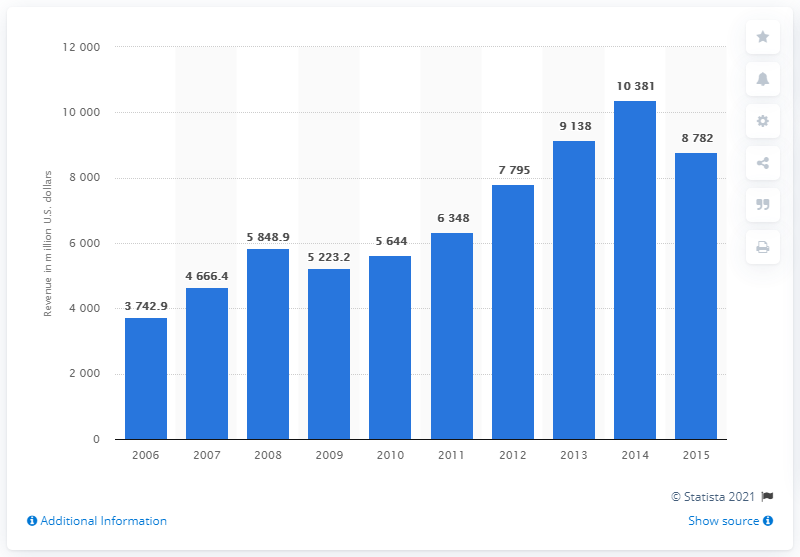Point out several critical features in this image. In 2006, Cameron International's annual revenue was approximately 3742.9 million US dollars. 